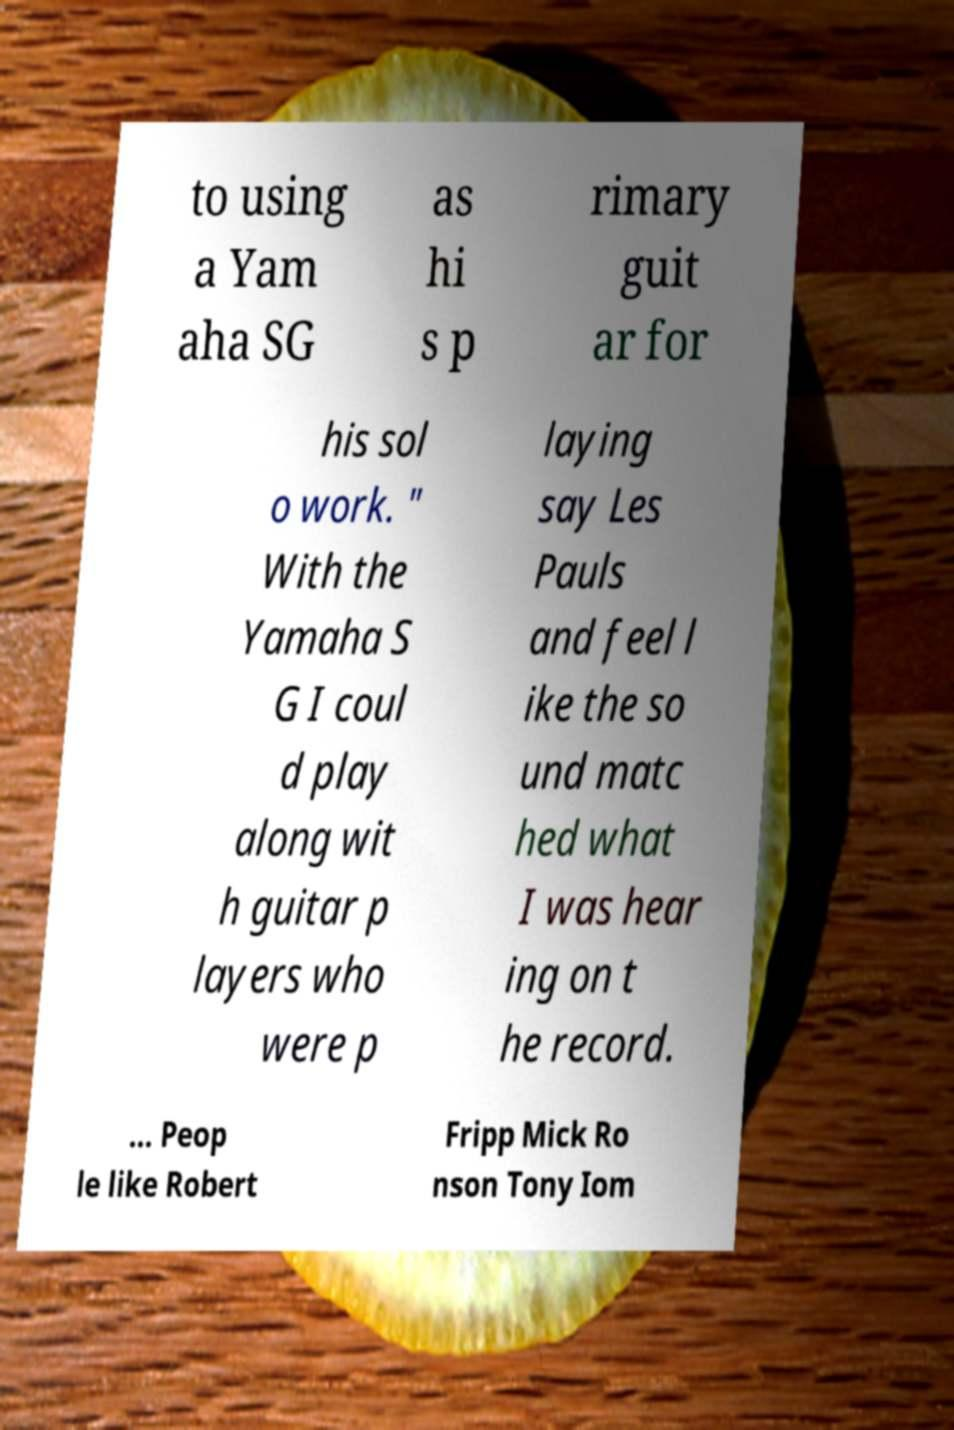What messages or text are displayed in this image? I need them in a readable, typed format. to using a Yam aha SG as hi s p rimary guit ar for his sol o work. " With the Yamaha S G I coul d play along wit h guitar p layers who were p laying say Les Pauls and feel l ike the so und matc hed what I was hear ing on t he record. ... Peop le like Robert Fripp Mick Ro nson Tony Iom 